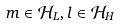Convert formula to latex. <formula><loc_0><loc_0><loc_500><loc_500>m \in { \mathcal { H } } _ { L } , l \in { \mathcal { H } } _ { H }</formula> 